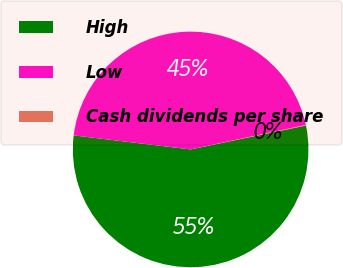<chart> <loc_0><loc_0><loc_500><loc_500><pie_chart><fcel>High<fcel>Low<fcel>Cash dividends per share<nl><fcel>55.16%<fcel>44.76%<fcel>0.08%<nl></chart> 